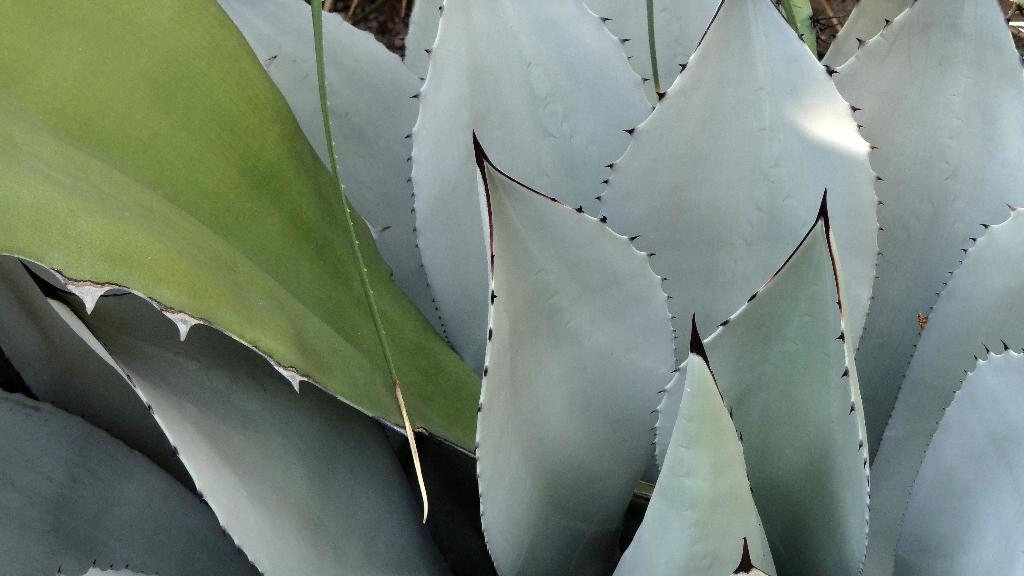What type of leaves are at the bottom of the image? There are gray color leaves of a plant at the bottom of the image. Where are the green color leaves located in the image? There are two green color leaves on the top left of the image. Can you describe the background of the image? The background of the image is blurred. What type of beam is holding up the plant in the image? There is no beam present in the image; it only features leaves of a plant. 